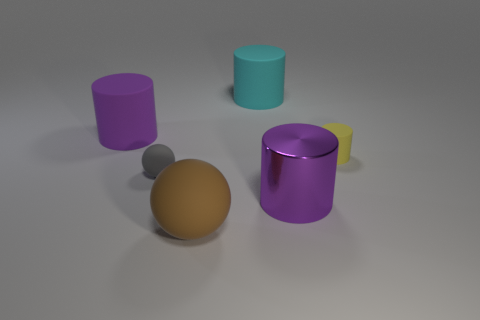There is a object that is the same color as the metallic cylinder; what material is it?
Ensure brevity in your answer.  Rubber. There is a tiny object on the left side of the small matte object that is to the right of the cyan thing; what shape is it?
Make the answer very short. Sphere. Is the number of large purple metal objects that are to the left of the brown ball less than the number of cyan objects behind the gray ball?
Your answer should be compact. Yes. There is a gray object that is the same shape as the brown object; what size is it?
Offer a very short reply. Small. Are there any other things that have the same size as the cyan rubber cylinder?
Make the answer very short. Yes. How many objects are spheres behind the brown object or things behind the tiny matte ball?
Offer a very short reply. 4. Is the gray thing the same size as the yellow cylinder?
Offer a terse response. Yes. Are there more large brown rubber balls than purple cylinders?
Give a very brief answer. No. What number of other objects are there of the same color as the large metal cylinder?
Your answer should be compact. 1. How many objects are either balls or small cylinders?
Provide a succinct answer. 3. 